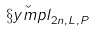Convert formula to latex. <formula><loc_0><loc_0><loc_500><loc_500>\check { \S y m p l } _ { 2 n , L , P }</formula> 